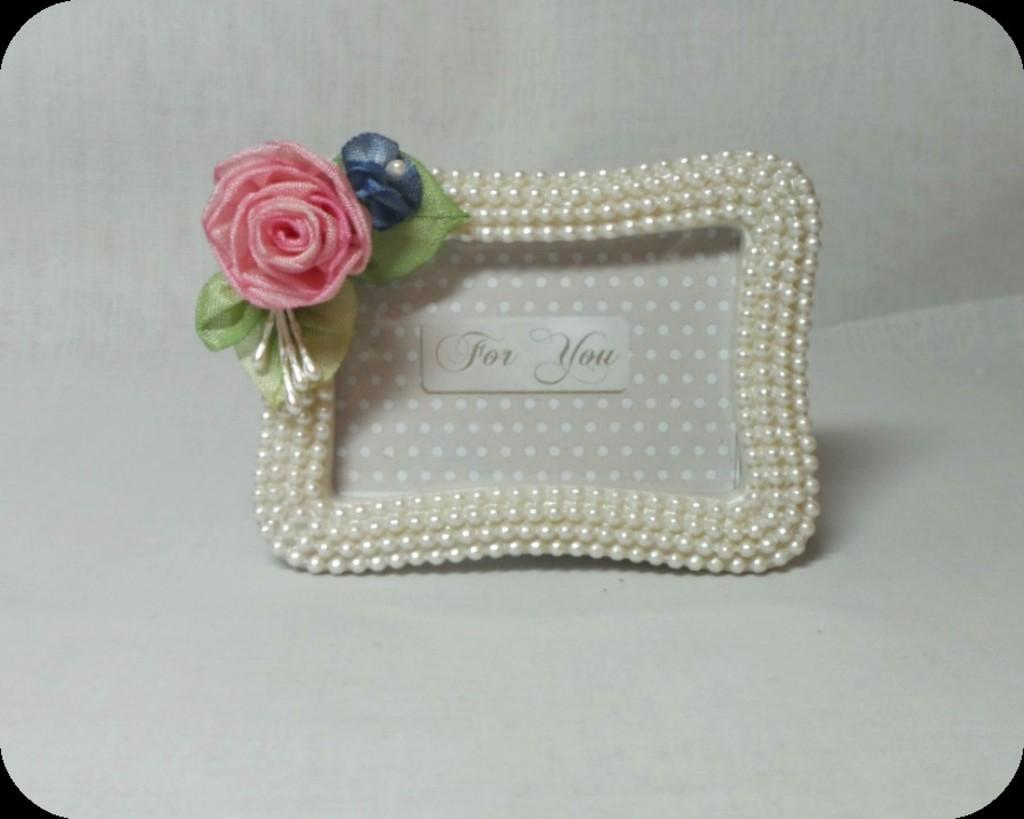What object in the image resembles a photo frame? There is an object that looks like a photo frame in the image. What is featured on the photo frame-like object? There is text on the photo frame-like object. What type of decorative item can be seen in the image? There is an artificial flower with leaves in the image. What additional detail can be observed on the photo frame-like object? There are beads on the frame. Can you tell me the price of the linen item in the image? There is no linen item present in the image. How old is the baby in the image? There is no baby present in the image. 